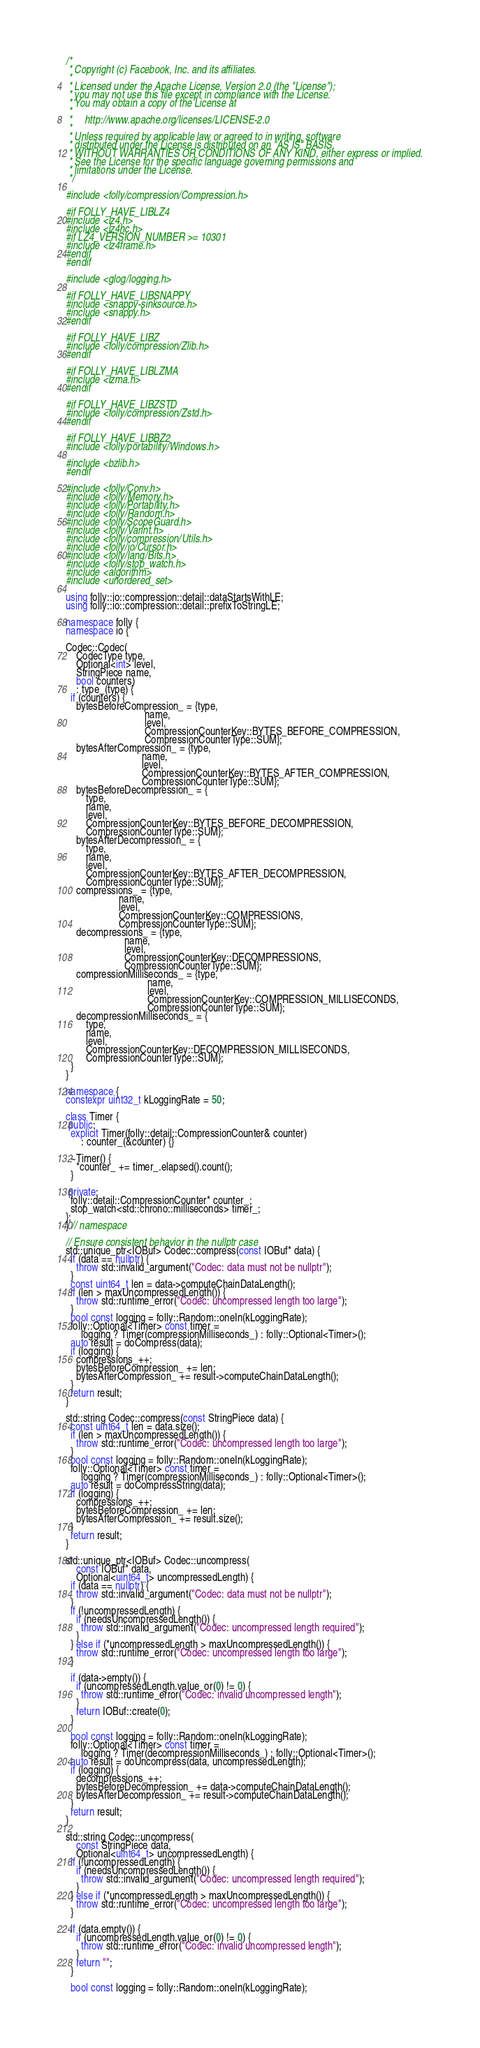<code> <loc_0><loc_0><loc_500><loc_500><_C++_>/*
 * Copyright (c) Facebook, Inc. and its affiliates.
 *
 * Licensed under the Apache License, Version 2.0 (the "License");
 * you may not use this file except in compliance with the License.
 * You may obtain a copy of the License at
 *
 *     http://www.apache.org/licenses/LICENSE-2.0
 *
 * Unless required by applicable law or agreed to in writing, software
 * distributed under the License is distributed on an "AS IS" BASIS,
 * WITHOUT WARRANTIES OR CONDITIONS OF ANY KIND, either express or implied.
 * See the License for the specific language governing permissions and
 * limitations under the License.
 */

#include <folly/compression/Compression.h>

#if FOLLY_HAVE_LIBLZ4
#include <lz4.h>
#include <lz4hc.h>
#if LZ4_VERSION_NUMBER >= 10301
#include <lz4frame.h>
#endif
#endif

#include <glog/logging.h>

#if FOLLY_HAVE_LIBSNAPPY
#include <snappy-sinksource.h>
#include <snappy.h>
#endif

#if FOLLY_HAVE_LIBZ
#include <folly/compression/Zlib.h>
#endif

#if FOLLY_HAVE_LIBLZMA
#include <lzma.h>
#endif

#if FOLLY_HAVE_LIBZSTD
#include <folly/compression/Zstd.h>
#endif

#if FOLLY_HAVE_LIBBZ2
#include <folly/portability/Windows.h>

#include <bzlib.h>
#endif

#include <folly/Conv.h>
#include <folly/Memory.h>
#include <folly/Portability.h>
#include <folly/Random.h>
#include <folly/ScopeGuard.h>
#include <folly/Varint.h>
#include <folly/compression/Utils.h>
#include <folly/io/Cursor.h>
#include <folly/lang/Bits.h>
#include <folly/stop_watch.h>
#include <algorithm>
#include <unordered_set>

using folly::io::compression::detail::dataStartsWithLE;
using folly::io::compression::detail::prefixToStringLE;

namespace folly {
namespace io {

Codec::Codec(
    CodecType type,
    Optional<int> level,
    StringPiece name,
    bool counters)
    : type_(type) {
  if (counters) {
    bytesBeforeCompression_ = {type,
                               name,
                               level,
                               CompressionCounterKey::BYTES_BEFORE_COMPRESSION,
                               CompressionCounterType::SUM};
    bytesAfterCompression_ = {type,
                              name,
                              level,
                              CompressionCounterKey::BYTES_AFTER_COMPRESSION,
                              CompressionCounterType::SUM};
    bytesBeforeDecompression_ = {
        type,
        name,
        level,
        CompressionCounterKey::BYTES_BEFORE_DECOMPRESSION,
        CompressionCounterType::SUM};
    bytesAfterDecompression_ = {
        type,
        name,
        level,
        CompressionCounterKey::BYTES_AFTER_DECOMPRESSION,
        CompressionCounterType::SUM};
    compressions_ = {type,
                     name,
                     level,
                     CompressionCounterKey::COMPRESSIONS,
                     CompressionCounterType::SUM};
    decompressions_ = {type,
                       name,
                       level,
                       CompressionCounterKey::DECOMPRESSIONS,
                       CompressionCounterType::SUM};
    compressionMilliseconds_ = {type,
                                name,
                                level,
                                CompressionCounterKey::COMPRESSION_MILLISECONDS,
                                CompressionCounterType::SUM};
    decompressionMilliseconds_ = {
        type,
        name,
        level,
        CompressionCounterKey::DECOMPRESSION_MILLISECONDS,
        CompressionCounterType::SUM};
  }
}

namespace {
constexpr uint32_t kLoggingRate = 50;

class Timer {
 public:
  explicit Timer(folly::detail::CompressionCounter& counter)
      : counter_(&counter) {}

  ~Timer() {
    *counter_ += timer_.elapsed().count();
  }

 private:
  folly::detail::CompressionCounter* counter_;
  stop_watch<std::chrono::milliseconds> timer_;
};
} // namespace

// Ensure consistent behavior in the nullptr case
std::unique_ptr<IOBuf> Codec::compress(const IOBuf* data) {
  if (data == nullptr) {
    throw std::invalid_argument("Codec: data must not be nullptr");
  }
  const uint64_t len = data->computeChainDataLength();
  if (len > maxUncompressedLength()) {
    throw std::runtime_error("Codec: uncompressed length too large");
  }
  bool const logging = folly::Random::oneIn(kLoggingRate);
  folly::Optional<Timer> const timer =
      logging ? Timer(compressionMilliseconds_) : folly::Optional<Timer>();
  auto result = doCompress(data);
  if (logging) {
    compressions_++;
    bytesBeforeCompression_ += len;
    bytesAfterCompression_ += result->computeChainDataLength();
  }
  return result;
}

std::string Codec::compress(const StringPiece data) {
  const uint64_t len = data.size();
  if (len > maxUncompressedLength()) {
    throw std::runtime_error("Codec: uncompressed length too large");
  }
  bool const logging = folly::Random::oneIn(kLoggingRate);
  folly::Optional<Timer> const timer =
      logging ? Timer(compressionMilliseconds_) : folly::Optional<Timer>();
  auto result = doCompressString(data);
  if (logging) {
    compressions_++;
    bytesBeforeCompression_ += len;
    bytesAfterCompression_ += result.size();
  }
  return result;
}

std::unique_ptr<IOBuf> Codec::uncompress(
    const IOBuf* data,
    Optional<uint64_t> uncompressedLength) {
  if (data == nullptr) {
    throw std::invalid_argument("Codec: data must not be nullptr");
  }
  if (!uncompressedLength) {
    if (needsUncompressedLength()) {
      throw std::invalid_argument("Codec: uncompressed length required");
    }
  } else if (*uncompressedLength > maxUncompressedLength()) {
    throw std::runtime_error("Codec: uncompressed length too large");
  }

  if (data->empty()) {
    if (uncompressedLength.value_or(0) != 0) {
      throw std::runtime_error("Codec: invalid uncompressed length");
    }
    return IOBuf::create(0);
  }

  bool const logging = folly::Random::oneIn(kLoggingRate);
  folly::Optional<Timer> const timer =
      logging ? Timer(decompressionMilliseconds_) : folly::Optional<Timer>();
  auto result = doUncompress(data, uncompressedLength);
  if (logging) {
    decompressions_++;
    bytesBeforeDecompression_ += data->computeChainDataLength();
    bytesAfterDecompression_ += result->computeChainDataLength();
  }
  return result;
}

std::string Codec::uncompress(
    const StringPiece data,
    Optional<uint64_t> uncompressedLength) {
  if (!uncompressedLength) {
    if (needsUncompressedLength()) {
      throw std::invalid_argument("Codec: uncompressed length required");
    }
  } else if (*uncompressedLength > maxUncompressedLength()) {
    throw std::runtime_error("Codec: uncompressed length too large");
  }

  if (data.empty()) {
    if (uncompressedLength.value_or(0) != 0) {
      throw std::runtime_error("Codec: invalid uncompressed length");
    }
    return "";
  }

  bool const logging = folly::Random::oneIn(kLoggingRate);</code> 